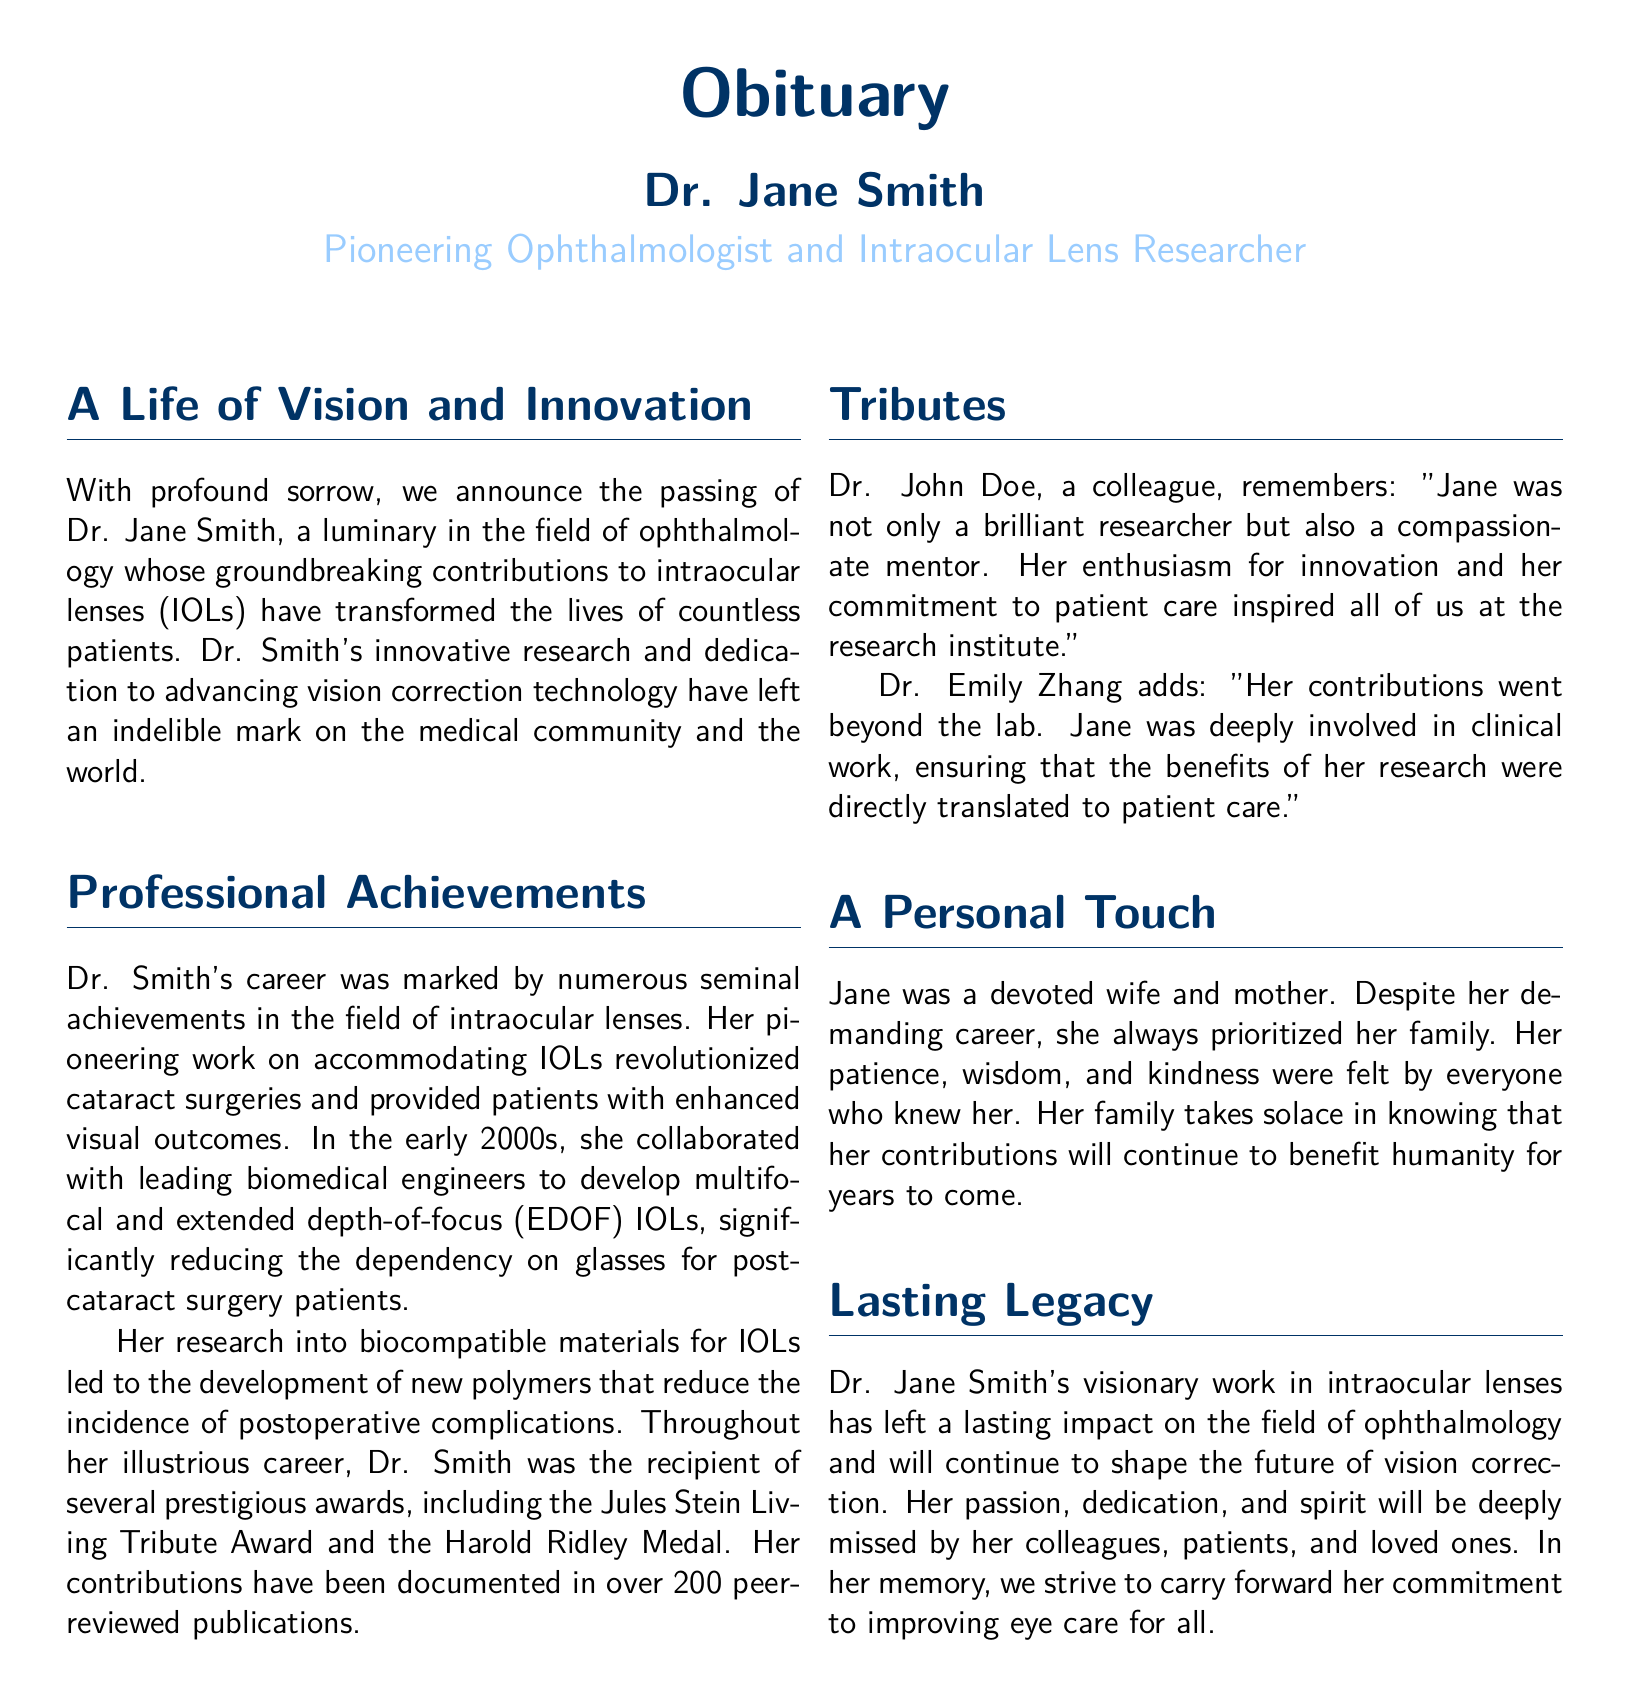What is the name of the ophthalmologist honored in the obituary? The document states the name of the honored ophthalmologist as Dr. Jane Smith.
Answer: Dr. Jane Smith What was Dr. Smith's notable contribution to cataract surgeries? The tribute highlights her pioneering work on accommodating IOLs, which revolutionized cataract surgeries.
Answer: Accommodating IOLs In what decade did Dr. Smith collaborate with biomedical engineers? The document specifies that her collaboration occurred in the early 2000s.
Answer: Early 2000s How many peer-reviewed publications did Dr. Smith author? The obituary mentions that her contributions have been documented in over 200 peer-reviewed publications.
Answer: Over 200 What award did Dr. Smith receive that highlights her legacy? The document lists the Jules Stein Living Tribute Award as one of the prestigious awards she received.
Answer: Jules Stein Living Tribute Award What aspect of Dr. Smith's character was highlighted by her colleague Dr. John Doe? Dr. John Doe emphasized her characteristics as a brilliant researcher and a compassionate mentor.
Answer: Compassionate mentor What was one of the materials Dr. Smith researched to improve IOLs? The obituary notes her research into biocompatible materials that led to new polymers for IOLs.
Answer: Biocompatible materials How did Dr. Smith ensure her research benefits patients? The document indicates that she was deeply involved in clinical work to translate her research into patient care.
Answer: Clinical work What personal role did Dr. Smith prioritize despite her career? The document states that she always prioritized her role as a devoted wife and mother.
Answer: Devoted wife and mother 